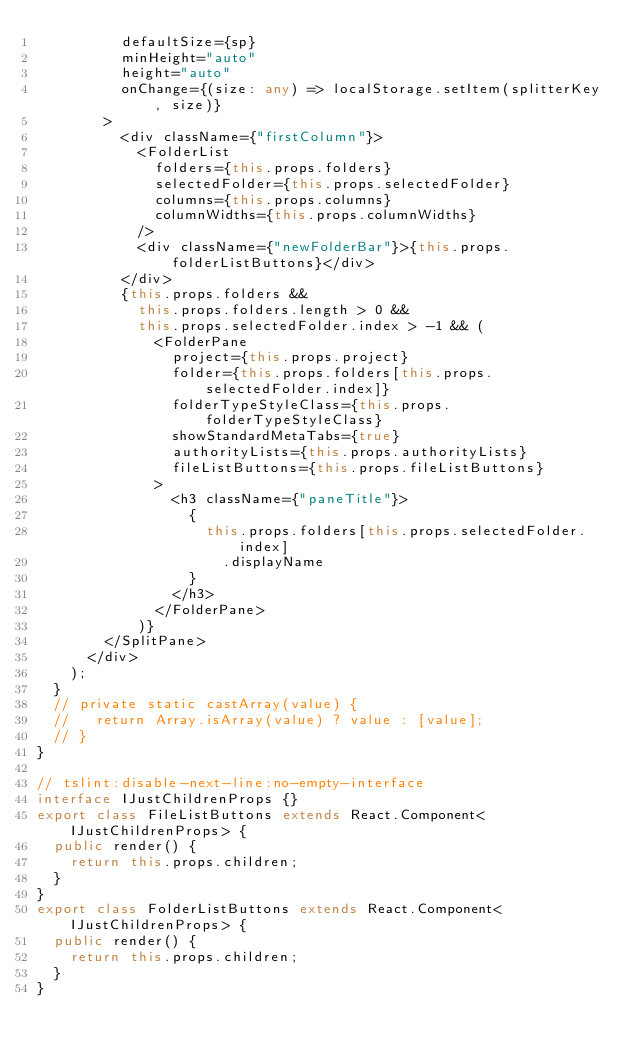<code> <loc_0><loc_0><loc_500><loc_500><_TypeScript_>          defaultSize={sp}
          minHeight="auto"
          height="auto"
          onChange={(size: any) => localStorage.setItem(splitterKey, size)}
        >
          <div className={"firstColumn"}>
            <FolderList
              folders={this.props.folders}
              selectedFolder={this.props.selectedFolder}
              columns={this.props.columns}
              columnWidths={this.props.columnWidths}
            />
            <div className={"newFolderBar"}>{this.props.folderListButtons}</div>
          </div>
          {this.props.folders &&
            this.props.folders.length > 0 &&
            this.props.selectedFolder.index > -1 && (
              <FolderPane
                project={this.props.project}
                folder={this.props.folders[this.props.selectedFolder.index]}
                folderTypeStyleClass={this.props.folderTypeStyleClass}
                showStandardMetaTabs={true}
                authorityLists={this.props.authorityLists}
                fileListButtons={this.props.fileListButtons}
              >
                <h3 className={"paneTitle"}>
                  {
                    this.props.folders[this.props.selectedFolder.index]
                      .displayName
                  }
                </h3>
              </FolderPane>
            )}
        </SplitPane>
      </div>
    );
  }
  // private static castArray(value) {
  //   return Array.isArray(value) ? value : [value];
  // }
}

// tslint:disable-next-line:no-empty-interface
interface IJustChildrenProps {}
export class FileListButtons extends React.Component<IJustChildrenProps> {
  public render() {
    return this.props.children;
  }
}
export class FolderListButtons extends React.Component<IJustChildrenProps> {
  public render() {
    return this.props.children;
  }
}
</code> 